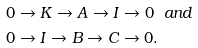<formula> <loc_0><loc_0><loc_500><loc_500>& 0 \rightarrow K \rightarrow A \rightarrow I \rightarrow 0 \ \ a n d \\ & 0 \rightarrow I \rightarrow B \rightarrow C \rightarrow 0 .</formula> 